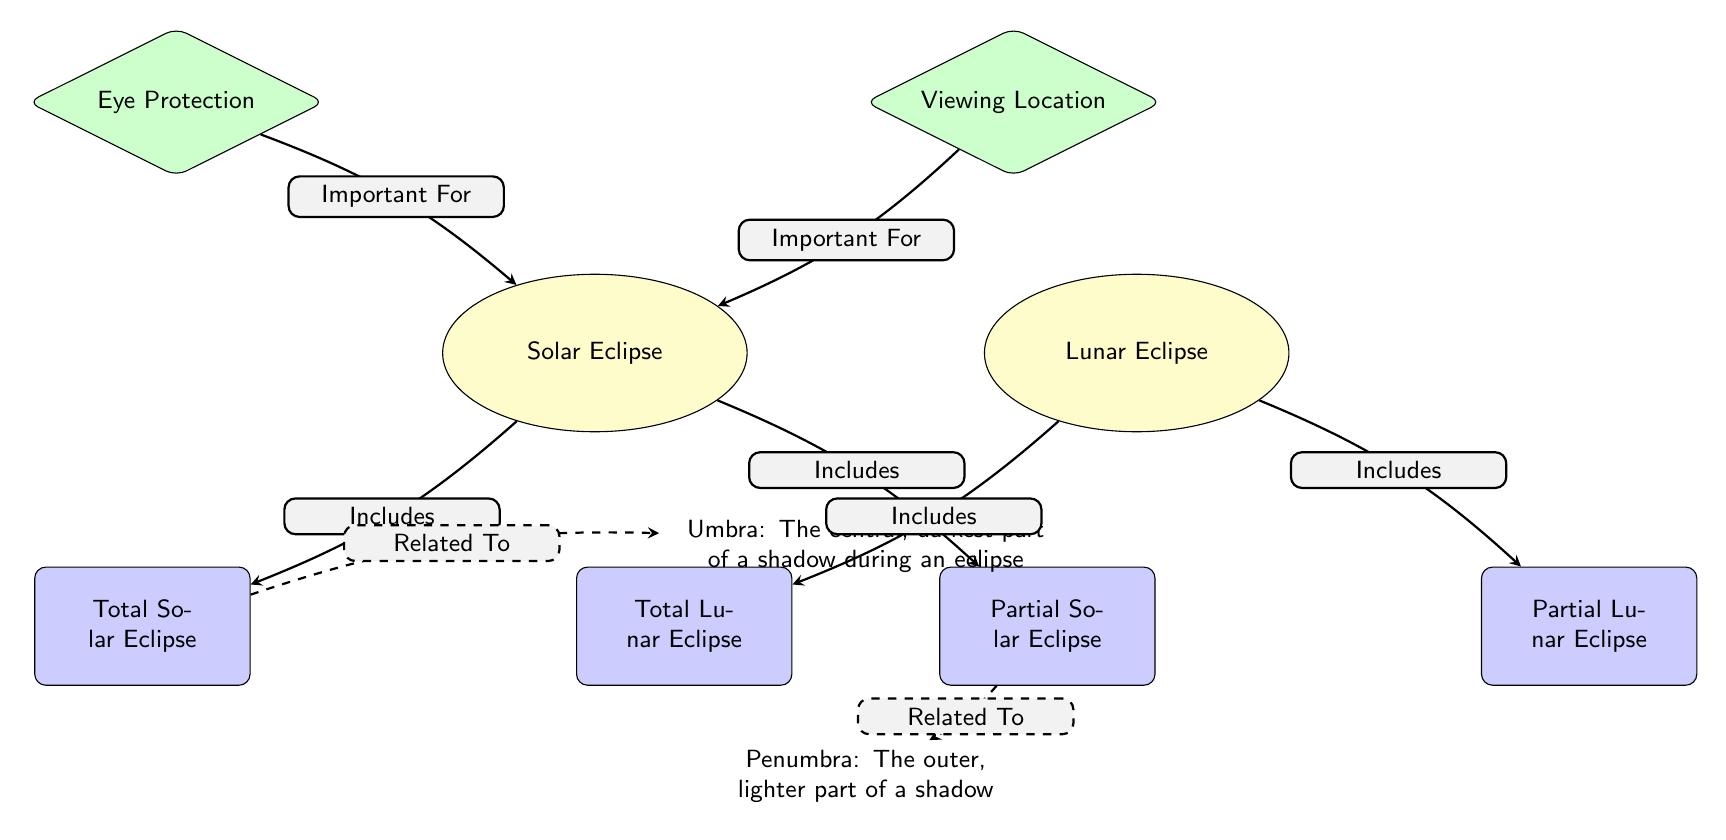What types of eclipses are included under solar eclipses? The diagram shows that a solar eclipse includes two types: Total Solar Eclipse and Partial Solar Eclipse. This can be determined by following the edge labeled "Includes" from the Solar Eclipse node to the two types listed below it.
Answer: Total Solar Eclipse, Partial Solar Eclipse What is the relationship between total solar eclipses and the umbra? The diagram indicates that Total Solar Eclipse is related to the Umbra through a dashed edge labeled "Related To." This means that there is a connection specified in the diagram, showing that the phenomenon is associated with the umbra.
Answer: Umbra What two tips are provided for viewing solar eclipses? The diagram displays two tips for viewing solar eclipses: Eye Protection and Viewing Location. These tips are presented as separate nodes above the solar eclipse node, connected by edges indicating their importance for viewing conditions.
Answer: Eye Protection, Viewing Location How many types of lunar eclipses are illustrated in the diagram? The diagram specifies that there are two types of lunar eclipses: Total Lunar Eclipse and Partial Lunar Eclipse, which can be found under the Lunar Eclipse node. By counting the types listed in relation to the lunar eclipse, we find that there are indeed two types.
Answer: 2 What distinguishes the umbra from the penumbra in the context of eclipses? The diagram defines the umbra as the central, darkest part of a shadow during an eclipse, while the penumbra is described as the outer, lighter part of a shadow. This distinction is crucial for understanding the visual effects during different types of eclipses.
Answer: Umbra: darkest, Penumbra: lighter What does the edge labeled "Important For" connect to the solar eclipse node? The diagram shows two nodes connected by edges labeled "Important For" to the solar eclipse node: Eye Protection and Viewing Location. This implies that both factors are crucial for safely observing a solar eclipse, as indicated in the diagram.
Answer: Eye Protection, Viewing Location 